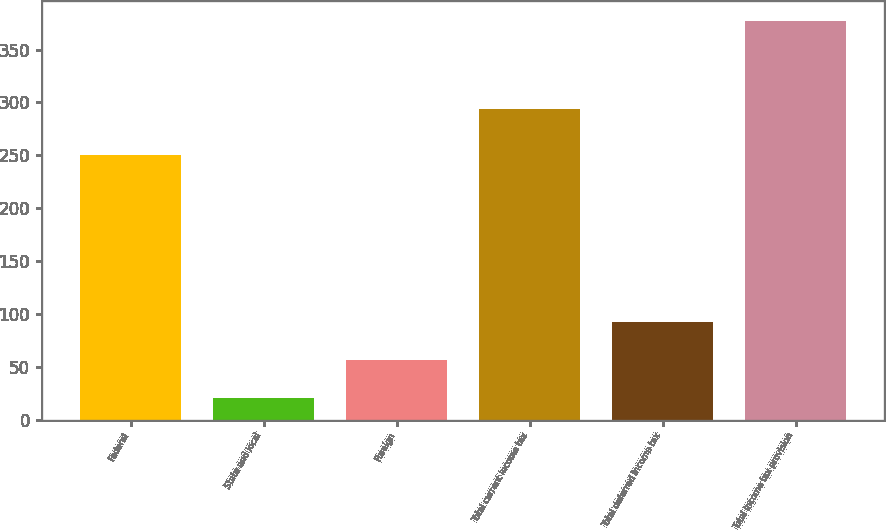Convert chart. <chart><loc_0><loc_0><loc_500><loc_500><bar_chart><fcel>Federal<fcel>State and local<fcel>Foreign<fcel>Total current income tax<fcel>Total deferred income tax<fcel>Total income tax provision<nl><fcel>250<fcel>21<fcel>56.6<fcel>294<fcel>92.2<fcel>377<nl></chart> 